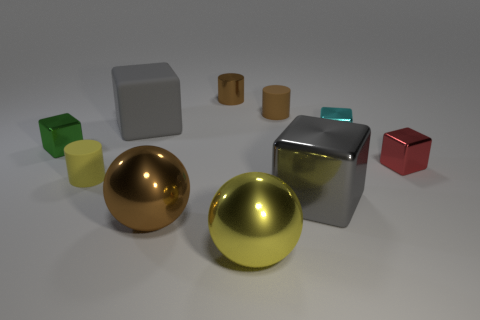Subtract all tiny cyan blocks. How many blocks are left? 4 Subtract all brown spheres. How many spheres are left? 1 Subtract all cylinders. How many objects are left? 7 Subtract all gray cylinders. How many cyan balls are left? 0 Subtract 0 cyan cylinders. How many objects are left? 10 Subtract 1 cubes. How many cubes are left? 4 Subtract all yellow balls. Subtract all blue cylinders. How many balls are left? 1 Subtract all big objects. Subtract all big cyan shiny blocks. How many objects are left? 6 Add 6 matte blocks. How many matte blocks are left? 7 Add 1 small green objects. How many small green objects exist? 2 